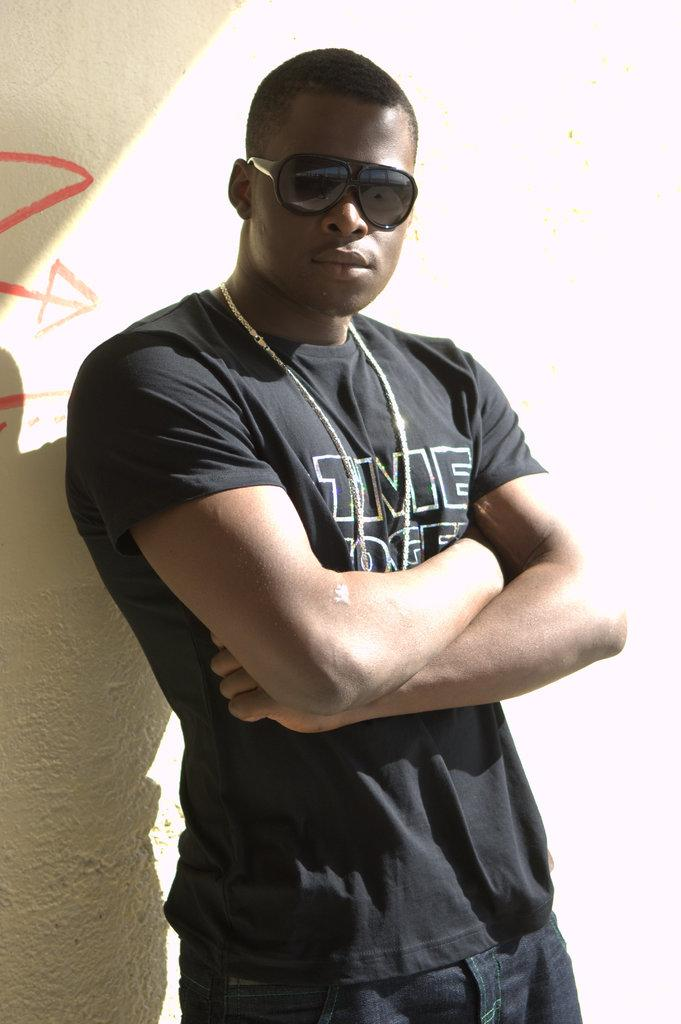Who is the main subject in the image? There is a man in the image. What is the man wearing? The man is wearing a black t-shirt. What is the man doing in the image? The man is standing, folding his hands, and posing for the picture. What can be seen in the background of the image? There is a wall in the background of the image. What type of pump is visible in the image? There is no pump present in the image. How does the man's afterthought affect the image? The man's afterthought is not mentioned in the image, so it cannot be determined how it affects the image. 